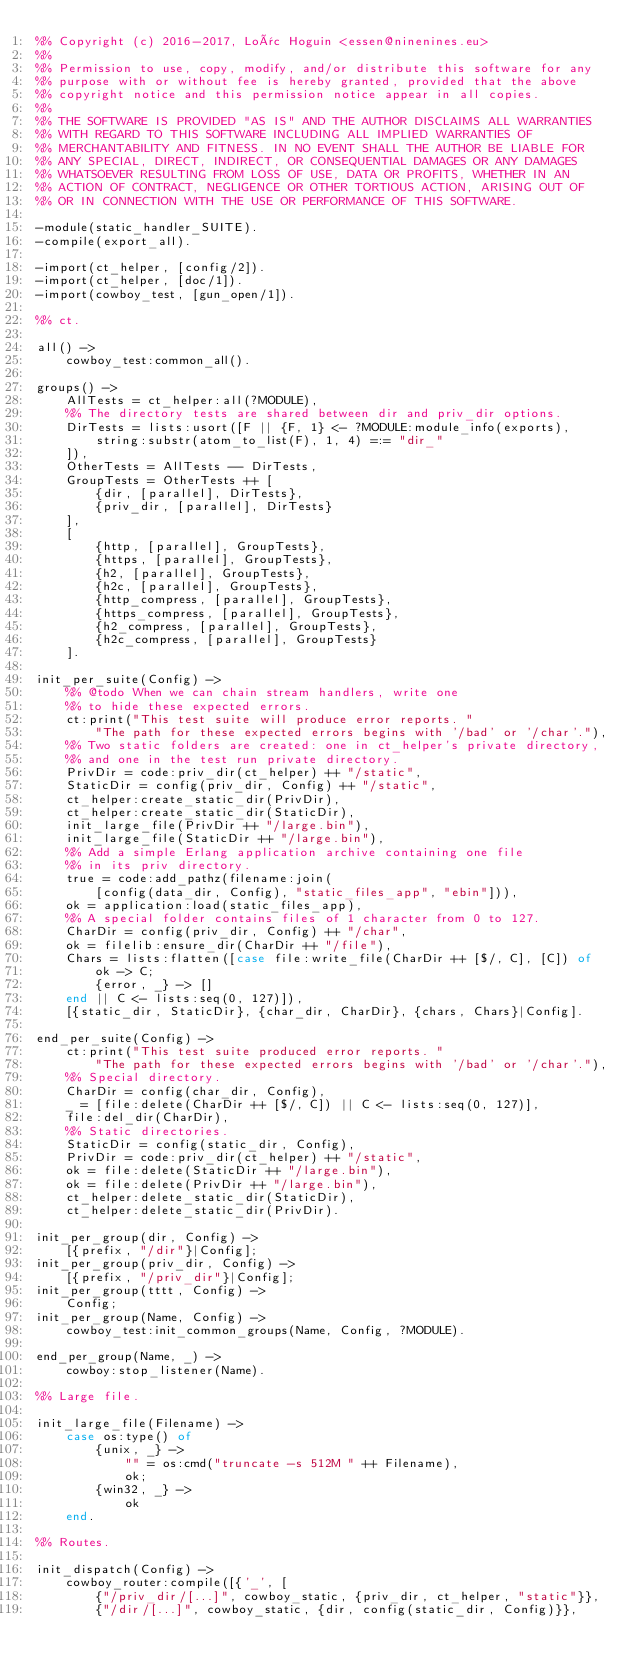<code> <loc_0><loc_0><loc_500><loc_500><_Erlang_>%% Copyright (c) 2016-2017, Loïc Hoguin <essen@ninenines.eu>
%%
%% Permission to use, copy, modify, and/or distribute this software for any
%% purpose with or without fee is hereby granted, provided that the above
%% copyright notice and this permission notice appear in all copies.
%%
%% THE SOFTWARE IS PROVIDED "AS IS" AND THE AUTHOR DISCLAIMS ALL WARRANTIES
%% WITH REGARD TO THIS SOFTWARE INCLUDING ALL IMPLIED WARRANTIES OF
%% MERCHANTABILITY AND FITNESS. IN NO EVENT SHALL THE AUTHOR BE LIABLE FOR
%% ANY SPECIAL, DIRECT, INDIRECT, OR CONSEQUENTIAL DAMAGES OR ANY DAMAGES
%% WHATSOEVER RESULTING FROM LOSS OF USE, DATA OR PROFITS, WHETHER IN AN
%% ACTION OF CONTRACT, NEGLIGENCE OR OTHER TORTIOUS ACTION, ARISING OUT OF
%% OR IN CONNECTION WITH THE USE OR PERFORMANCE OF THIS SOFTWARE.

-module(static_handler_SUITE).
-compile(export_all).

-import(ct_helper, [config/2]).
-import(ct_helper, [doc/1]).
-import(cowboy_test, [gun_open/1]).

%% ct.

all() ->
	cowboy_test:common_all().

groups() ->
	AllTests = ct_helper:all(?MODULE),
	%% The directory tests are shared between dir and priv_dir options.
	DirTests = lists:usort([F || {F, 1} <- ?MODULE:module_info(exports),
		string:substr(atom_to_list(F), 1, 4) =:= "dir_"
	]),
	OtherTests = AllTests -- DirTests,
	GroupTests = OtherTests ++ [
		{dir, [parallel], DirTests},
		{priv_dir, [parallel], DirTests}
	],
	[
		{http, [parallel], GroupTests},
		{https, [parallel], GroupTests},
		{h2, [parallel], GroupTests},
		{h2c, [parallel], GroupTests},
		{http_compress, [parallel], GroupTests},
		{https_compress, [parallel], GroupTests},
		{h2_compress, [parallel], GroupTests},
		{h2c_compress, [parallel], GroupTests}
	].

init_per_suite(Config) ->
	%% @todo When we can chain stream handlers, write one
	%% to hide these expected errors.
	ct:print("This test suite will produce error reports. "
		"The path for these expected errors begins with '/bad' or '/char'."),
	%% Two static folders are created: one in ct_helper's private directory,
	%% and one in the test run private directory.
	PrivDir = code:priv_dir(ct_helper) ++ "/static",
	StaticDir = config(priv_dir, Config) ++ "/static",
	ct_helper:create_static_dir(PrivDir),
	ct_helper:create_static_dir(StaticDir),
	init_large_file(PrivDir ++ "/large.bin"),
	init_large_file(StaticDir ++ "/large.bin"),
	%% Add a simple Erlang application archive containing one file
	%% in its priv directory.
	true = code:add_pathz(filename:join(
		[config(data_dir, Config), "static_files_app", "ebin"])),
	ok = application:load(static_files_app),
	%% A special folder contains files of 1 character from 0 to 127.
	CharDir = config(priv_dir, Config) ++ "/char",
	ok = filelib:ensure_dir(CharDir ++ "/file"),
	Chars = lists:flatten([case file:write_file(CharDir ++ [$/, C], [C]) of
		ok -> C;
		{error, _} -> []
	end || C <- lists:seq(0, 127)]),
	[{static_dir, StaticDir}, {char_dir, CharDir}, {chars, Chars}|Config].

end_per_suite(Config) ->
	ct:print("This test suite produced error reports. "
		"The path for these expected errors begins with '/bad' or '/char'."),
	%% Special directory.
	CharDir = config(char_dir, Config),
	_ = [file:delete(CharDir ++ [$/, C]) || C <- lists:seq(0, 127)],
	file:del_dir(CharDir),
	%% Static directories.
	StaticDir = config(static_dir, Config),
	PrivDir = code:priv_dir(ct_helper) ++ "/static",
	ok = file:delete(StaticDir ++ "/large.bin"),
	ok = file:delete(PrivDir ++ "/large.bin"),
	ct_helper:delete_static_dir(StaticDir),
	ct_helper:delete_static_dir(PrivDir).

init_per_group(dir, Config) ->
	[{prefix, "/dir"}|Config];
init_per_group(priv_dir, Config) ->
	[{prefix, "/priv_dir"}|Config];
init_per_group(tttt, Config) ->
	Config;
init_per_group(Name, Config) ->
	cowboy_test:init_common_groups(Name, Config, ?MODULE).

end_per_group(Name, _) ->
	cowboy:stop_listener(Name).

%% Large file.

init_large_file(Filename) ->
	case os:type() of
		{unix, _} ->
			"" = os:cmd("truncate -s 512M " ++ Filename),
			ok;
		{win32, _} ->
			ok
	end.

%% Routes.

init_dispatch(Config) ->
	cowboy_router:compile([{'_', [
		{"/priv_dir/[...]", cowboy_static, {priv_dir, ct_helper, "static"}},
		{"/dir/[...]", cowboy_static, {dir, config(static_dir, Config)}},</code> 